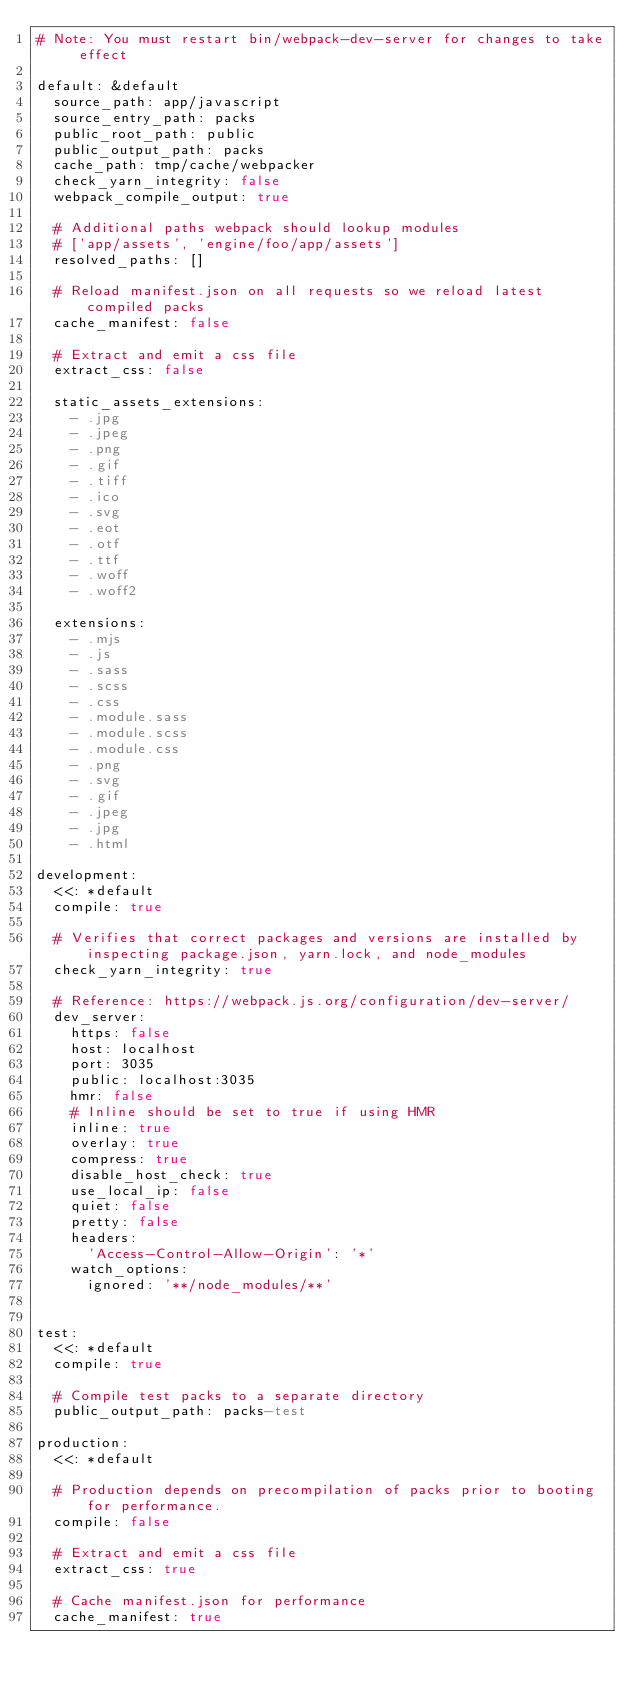<code> <loc_0><loc_0><loc_500><loc_500><_YAML_># Note: You must restart bin/webpack-dev-server for changes to take effect

default: &default
  source_path: app/javascript
  source_entry_path: packs
  public_root_path: public
  public_output_path: packs
  cache_path: tmp/cache/webpacker
  check_yarn_integrity: false
  webpack_compile_output: true

  # Additional paths webpack should lookup modules
  # ['app/assets', 'engine/foo/app/assets']
  resolved_paths: []

  # Reload manifest.json on all requests so we reload latest compiled packs
  cache_manifest: false

  # Extract and emit a css file
  extract_css: false

  static_assets_extensions:
    - .jpg
    - .jpeg
    - .png
    - .gif
    - .tiff
    - .ico
    - .svg
    - .eot
    - .otf
    - .ttf
    - .woff
    - .woff2

  extensions:
    - .mjs
    - .js
    - .sass
    - .scss
    - .css
    - .module.sass
    - .module.scss
    - .module.css
    - .png
    - .svg
    - .gif
    - .jpeg
    - .jpg
    - .html

development:
  <<: *default
  compile: true

  # Verifies that correct packages and versions are installed by inspecting package.json, yarn.lock, and node_modules
  check_yarn_integrity: true

  # Reference: https://webpack.js.org/configuration/dev-server/
  dev_server:
    https: false
    host: localhost
    port: 3035
    public: localhost:3035
    hmr: false
    # Inline should be set to true if using HMR
    inline: true
    overlay: true
    compress: true
    disable_host_check: true
    use_local_ip: false
    quiet: false
    pretty: false
    headers:
      'Access-Control-Allow-Origin': '*'
    watch_options:
      ignored: '**/node_modules/**'


test:
  <<: *default
  compile: true

  # Compile test packs to a separate directory
  public_output_path: packs-test

production:
  <<: *default

  # Production depends on precompilation of packs prior to booting for performance.
  compile: false

  # Extract and emit a css file
  extract_css: true

  # Cache manifest.json for performance
  cache_manifest: true
</code> 